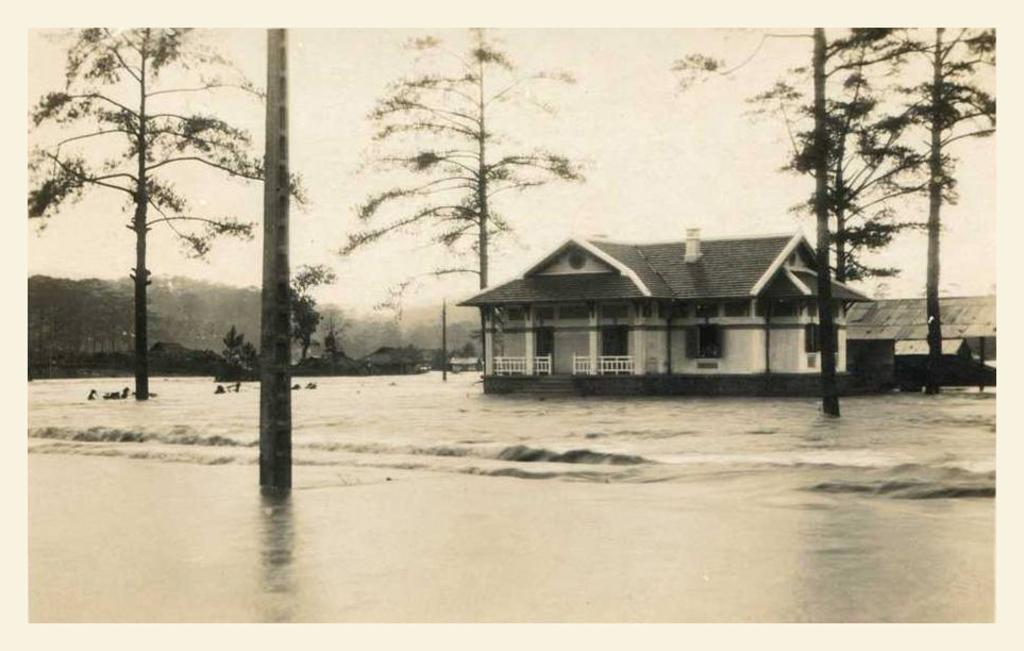What is the main element present in the image? There is water in the image. What other natural elements can be seen in the image? There are trees in the image. Are there any man-made structures visible? Yes, there are houses in the image. What is visible in the background of the image? The sky is visible in the image. What type of government is depicted in the image? There is no depiction of a government in the image; it features water, trees, houses, and the sky. 